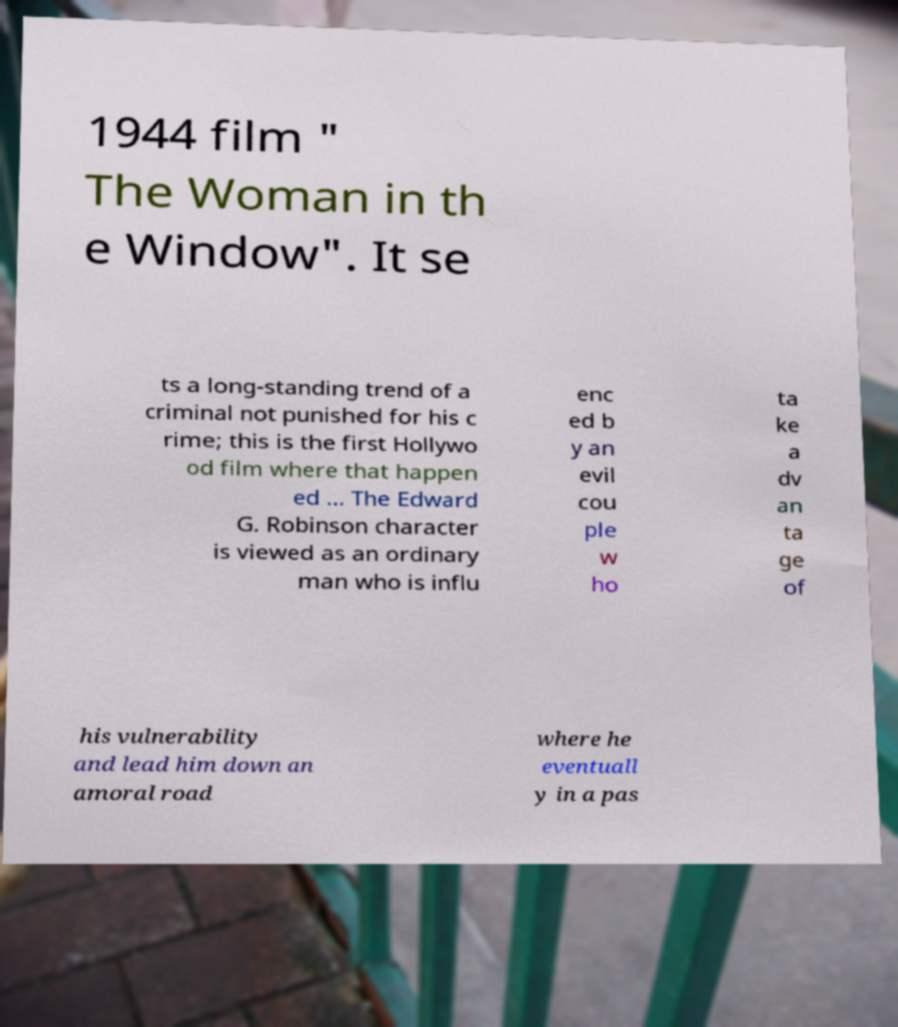Please read and relay the text visible in this image. What does it say? 1944 film " The Woman in th e Window". It se ts a long-standing trend of a criminal not punished for his c rime; this is the first Hollywo od film where that happen ed ... The Edward G. Robinson character is viewed as an ordinary man who is influ enc ed b y an evil cou ple w ho ta ke a dv an ta ge of his vulnerability and lead him down an amoral road where he eventuall y in a pas 